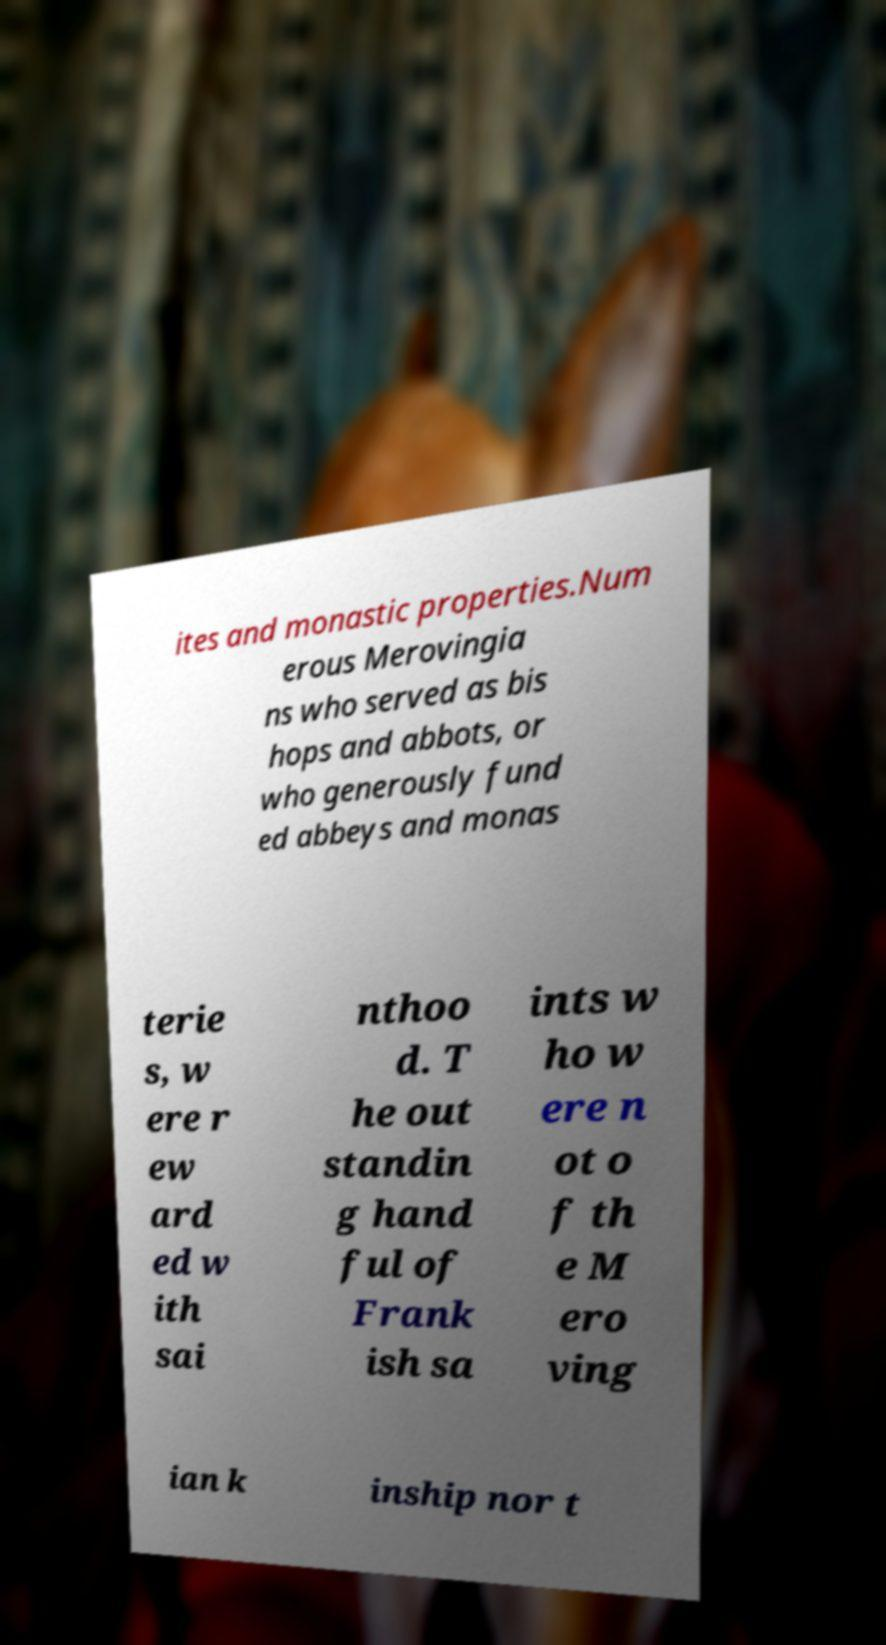For documentation purposes, I need the text within this image transcribed. Could you provide that? ites and monastic properties.Num erous Merovingia ns who served as bis hops and abbots, or who generously fund ed abbeys and monas terie s, w ere r ew ard ed w ith sai nthoo d. T he out standin g hand ful of Frank ish sa ints w ho w ere n ot o f th e M ero ving ian k inship nor t 